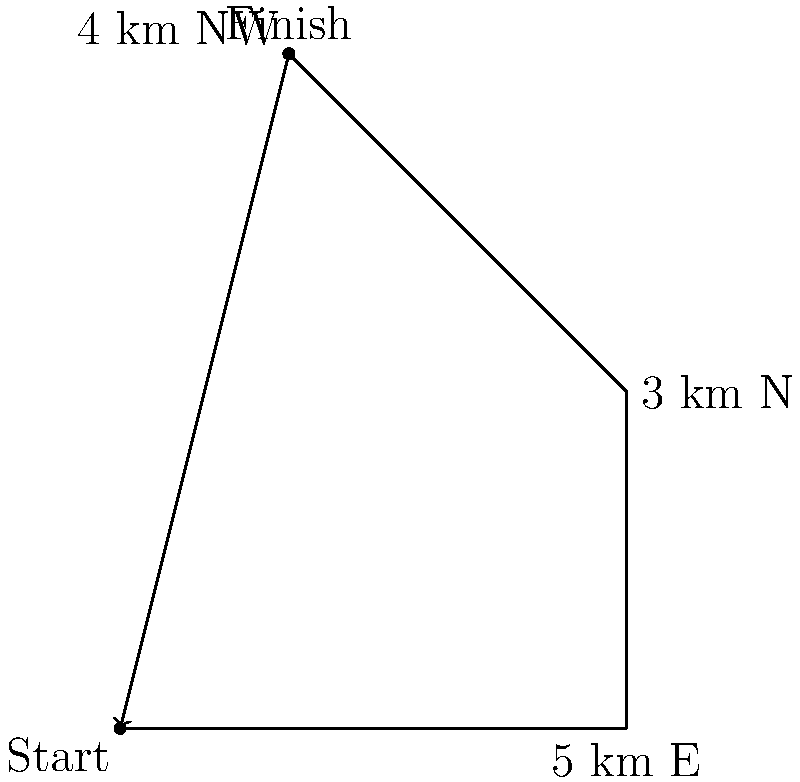A marathon runner starts at the origin and runs 5 km east, then 3 km north, and finally 4 km northwest. Using vector addition, calculate the straight-line distance and direction from the starting point to the finish line. Express the direction as an angle counterclockwise from the positive x-axis. Let's approach this step-by-step:

1) First, we need to represent each leg of the run as a vector:
   - 5 km east: $\vec{v}_1 = (5, 0)$
   - 3 km north: $\vec{v}_2 = (0, 3)$
   - 4 km northwest: $\vec{v}_3 = (-2\sqrt{2}, 2\sqrt{2})$ (since northwest is at a 45° angle)

2) The final position vector is the sum of these vectors:
   $\vec{v} = \vec{v}_1 + \vec{v}_2 + \vec{v}_3$
   $\vec{v} = (5, 0) + (0, 3) + (-2\sqrt{2}, 2\sqrt{2})$
   $\vec{v} = (5 - 2\sqrt{2}, 3 + 2\sqrt{2})$

3) To find the distance, we calculate the magnitude of this vector:
   $|\vec{v}| = \sqrt{(5 - 2\sqrt{2})^2 + (3 + 2\sqrt{2})^2}$
   $|\vec{v}| = \sqrt{25 - 20\sqrt{2} + 8 + 9 + 12\sqrt{2} + 8}$
   $|\vec{v}| = \sqrt{42 - 8\sqrt{2}} \approx 5.86$ km

4) To find the direction, we calculate the angle using arctan:
   $\theta = \tan^{-1}(\frac{3 + 2\sqrt{2}}{5 - 2\sqrt{2}})$
   $\theta \approx 1.09$ radians or 62.4°

Therefore, the runner finishes approximately 5.86 km from the starting point at an angle of 62.4° counterclockwise from the positive x-axis.
Answer: 5.86 km, 62.4° 